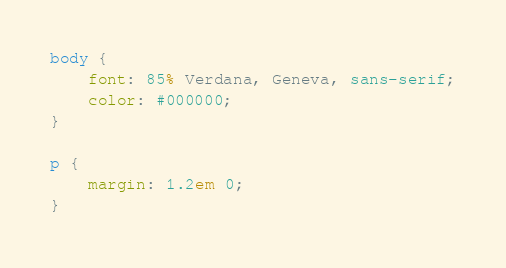<code> <loc_0><loc_0><loc_500><loc_500><_CSS_>
body {
	font: 85% Verdana, Geneva, sans-serif;
	color: #000000;
}

p {
	margin: 1.2em 0;
}

</code> 